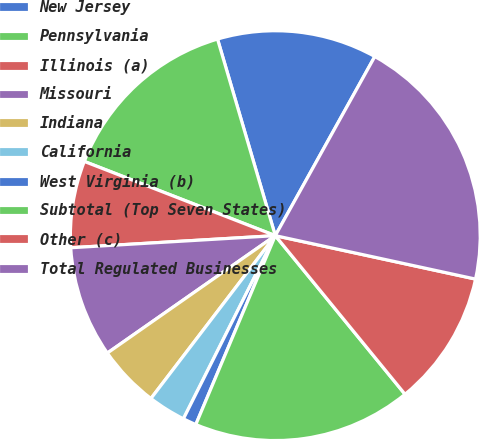Convert chart to OTSL. <chart><loc_0><loc_0><loc_500><loc_500><pie_chart><fcel>New Jersey<fcel>Pennsylvania<fcel>Illinois (a)<fcel>Missouri<fcel>Indiana<fcel>California<fcel>West Virginia (b)<fcel>Subtotal (Top Seven States)<fcel>Other (c)<fcel>Total Regulated Businesses<nl><fcel>12.62%<fcel>14.55%<fcel>6.84%<fcel>8.77%<fcel>4.91%<fcel>2.98%<fcel>1.06%<fcel>17.25%<fcel>10.69%<fcel>20.33%<nl></chart> 